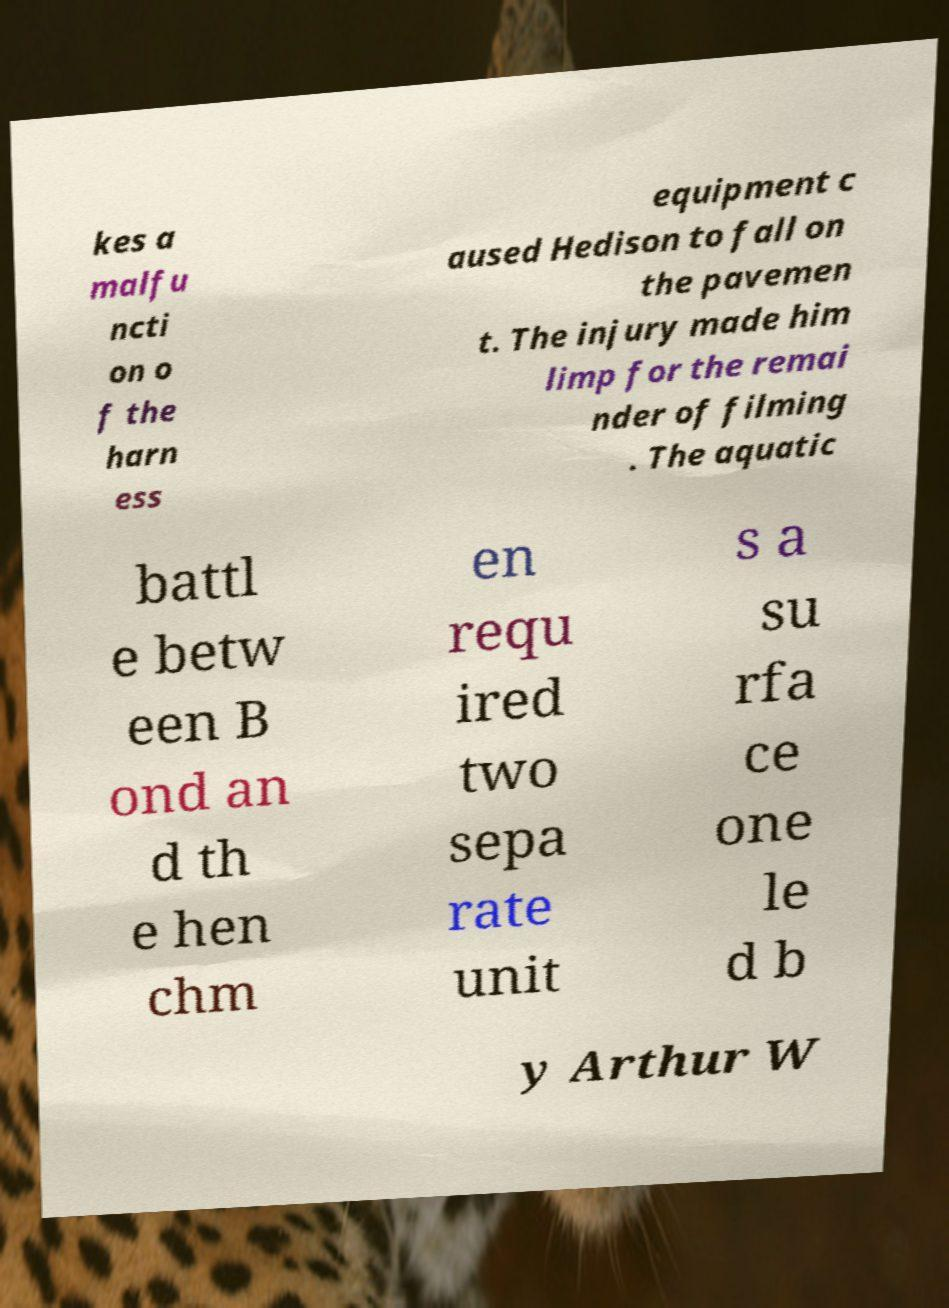I need the written content from this picture converted into text. Can you do that? kes a malfu ncti on o f the harn ess equipment c aused Hedison to fall on the pavemen t. The injury made him limp for the remai nder of filming . The aquatic battl e betw een B ond an d th e hen chm en requ ired two sepa rate unit s a su rfa ce one le d b y Arthur W 